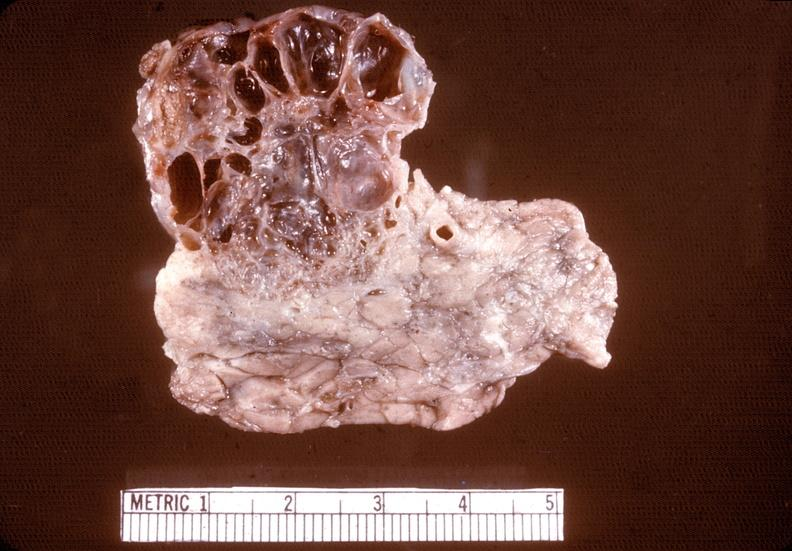does atheromatous embolus show cystadenoma?
Answer the question using a single word or phrase. No 